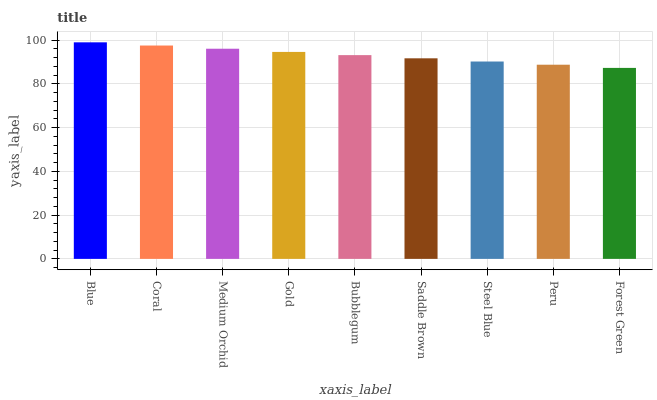Is Forest Green the minimum?
Answer yes or no. Yes. Is Blue the maximum?
Answer yes or no. Yes. Is Coral the minimum?
Answer yes or no. No. Is Coral the maximum?
Answer yes or no. No. Is Blue greater than Coral?
Answer yes or no. Yes. Is Coral less than Blue?
Answer yes or no. Yes. Is Coral greater than Blue?
Answer yes or no. No. Is Blue less than Coral?
Answer yes or no. No. Is Bubblegum the high median?
Answer yes or no. Yes. Is Bubblegum the low median?
Answer yes or no. Yes. Is Steel Blue the high median?
Answer yes or no. No. Is Blue the low median?
Answer yes or no. No. 